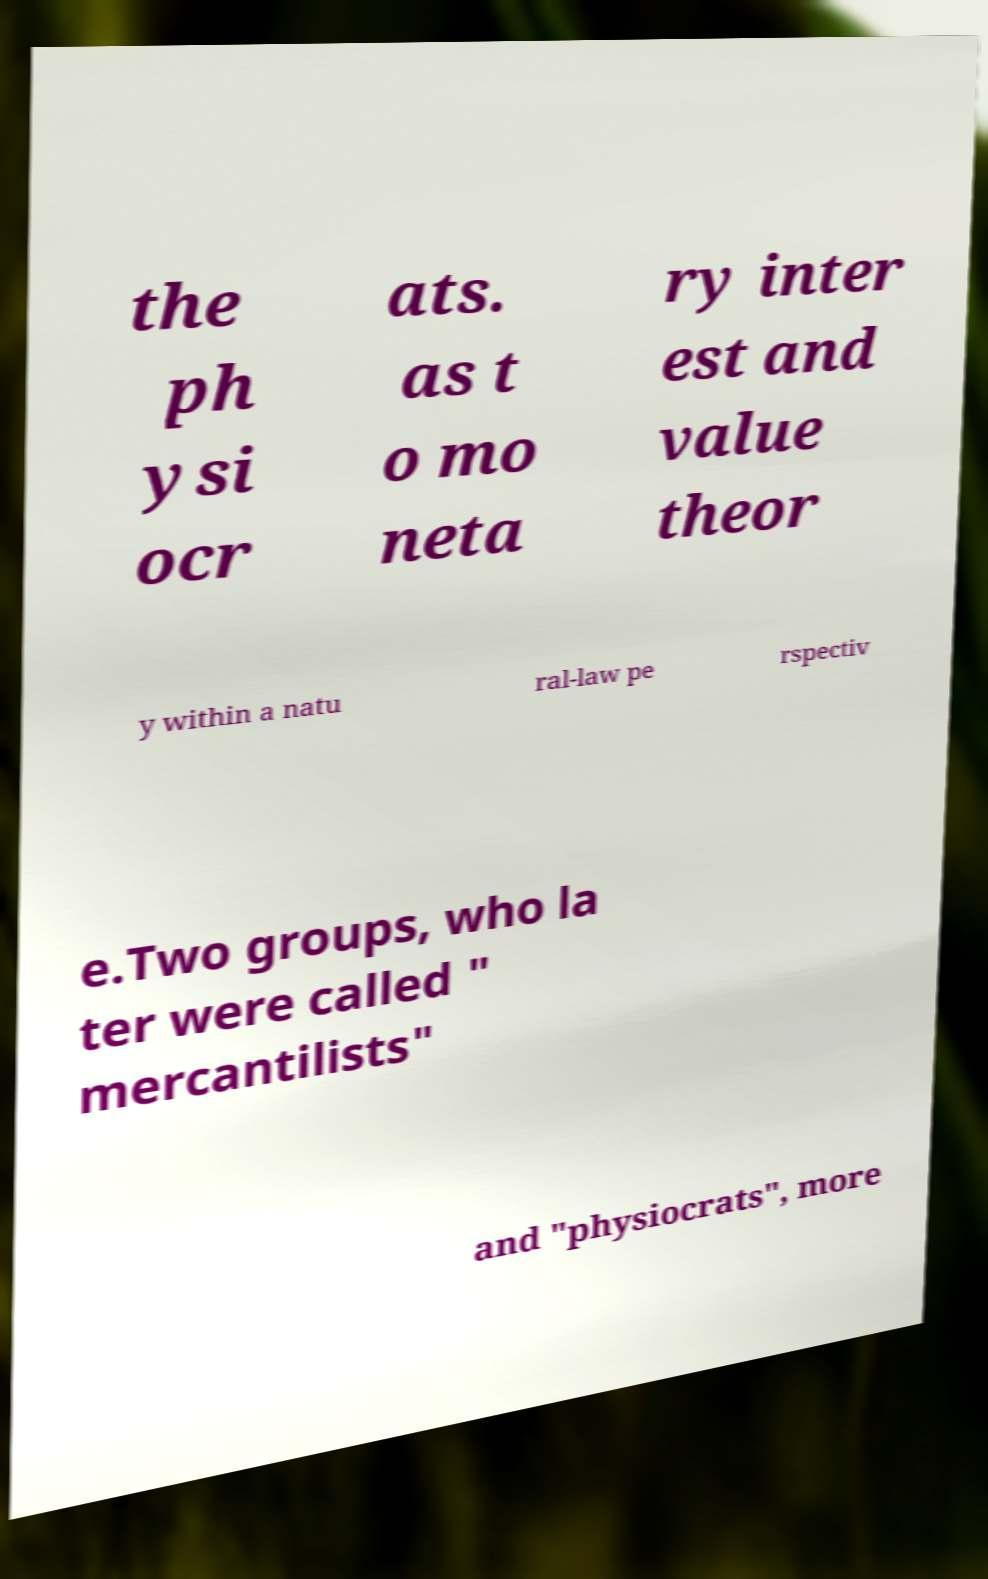For documentation purposes, I need the text within this image transcribed. Could you provide that? the ph ysi ocr ats. as t o mo neta ry inter est and value theor y within a natu ral-law pe rspectiv e.Two groups, who la ter were called " mercantilists" and "physiocrats", more 